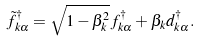Convert formula to latex. <formula><loc_0><loc_0><loc_500><loc_500>\tilde { f } ^ { \dagger } _ { k \alpha } = \sqrt { 1 - \beta _ { k } ^ { 2 } } f _ { k \alpha } ^ { \dagger } + \beta _ { k } d _ { k \alpha } ^ { \dagger } .</formula> 